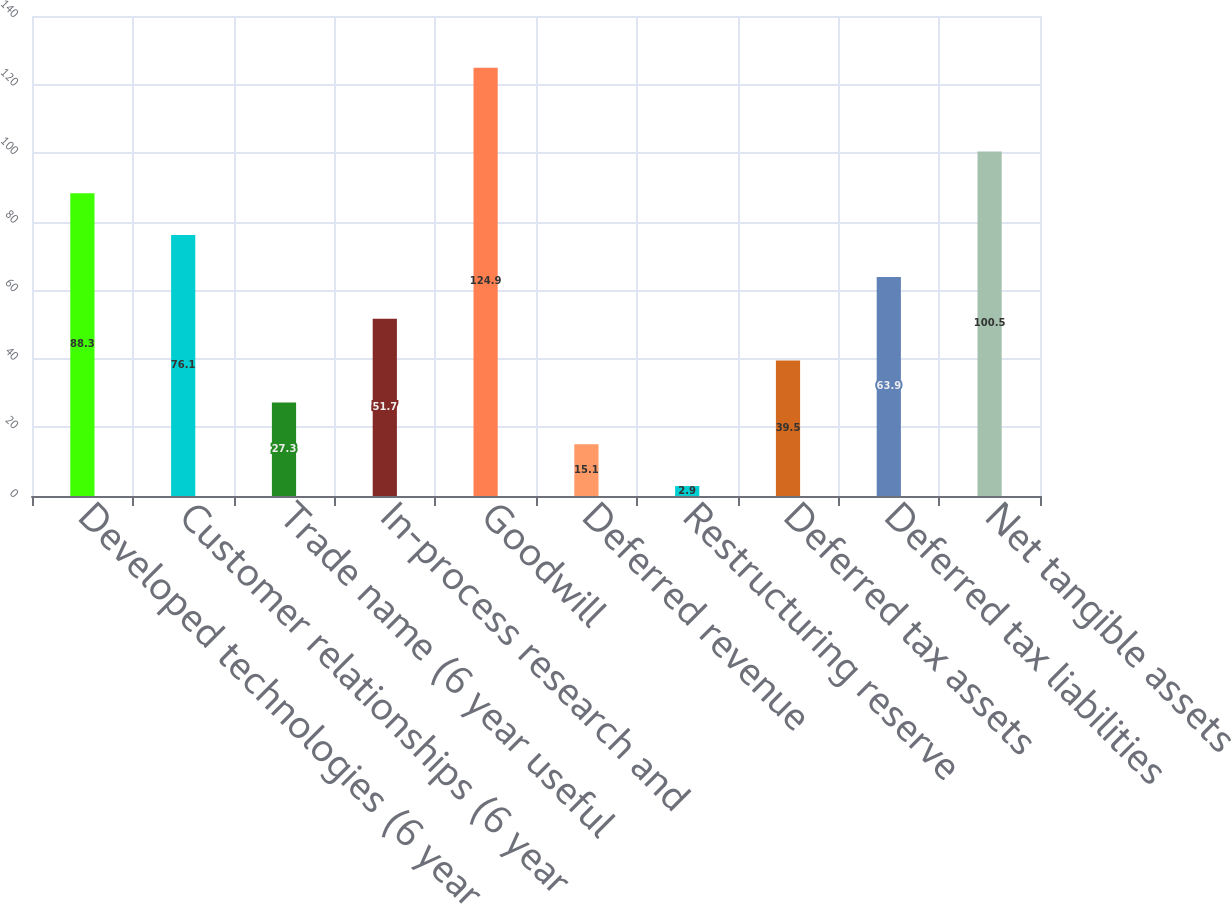Convert chart to OTSL. <chart><loc_0><loc_0><loc_500><loc_500><bar_chart><fcel>Developed technologies (6 year<fcel>Customer relationships (6 year<fcel>Trade name (6 year useful<fcel>In-process research and<fcel>Goodwill<fcel>Deferred revenue<fcel>Restructuring reserve<fcel>Deferred tax assets<fcel>Deferred tax liabilities<fcel>Net tangible assets<nl><fcel>88.3<fcel>76.1<fcel>27.3<fcel>51.7<fcel>124.9<fcel>15.1<fcel>2.9<fcel>39.5<fcel>63.9<fcel>100.5<nl></chart> 